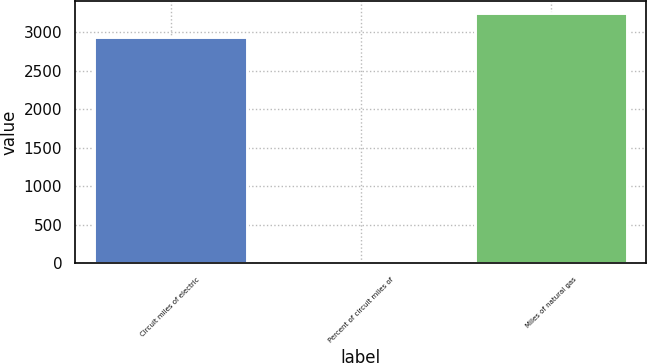<chart> <loc_0><loc_0><loc_500><loc_500><bar_chart><fcel>Circuit miles of electric<fcel>Percent of circuit miles of<fcel>Miles of natural gas<nl><fcel>2931<fcel>21<fcel>3243.4<nl></chart> 